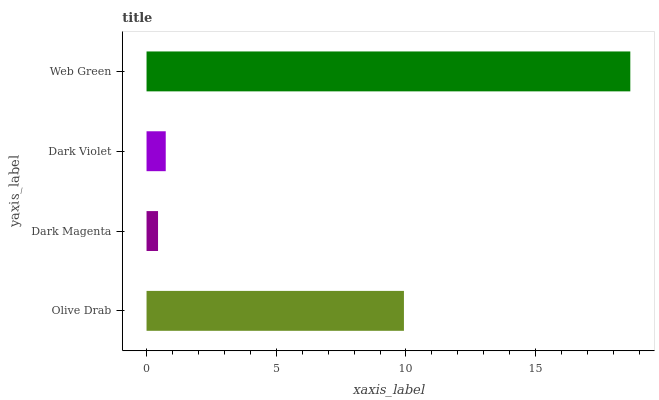Is Dark Magenta the minimum?
Answer yes or no. Yes. Is Web Green the maximum?
Answer yes or no. Yes. Is Dark Violet the minimum?
Answer yes or no. No. Is Dark Violet the maximum?
Answer yes or no. No. Is Dark Violet greater than Dark Magenta?
Answer yes or no. Yes. Is Dark Magenta less than Dark Violet?
Answer yes or no. Yes. Is Dark Magenta greater than Dark Violet?
Answer yes or no. No. Is Dark Violet less than Dark Magenta?
Answer yes or no. No. Is Olive Drab the high median?
Answer yes or no. Yes. Is Dark Violet the low median?
Answer yes or no. Yes. Is Dark Magenta the high median?
Answer yes or no. No. Is Web Green the low median?
Answer yes or no. No. 